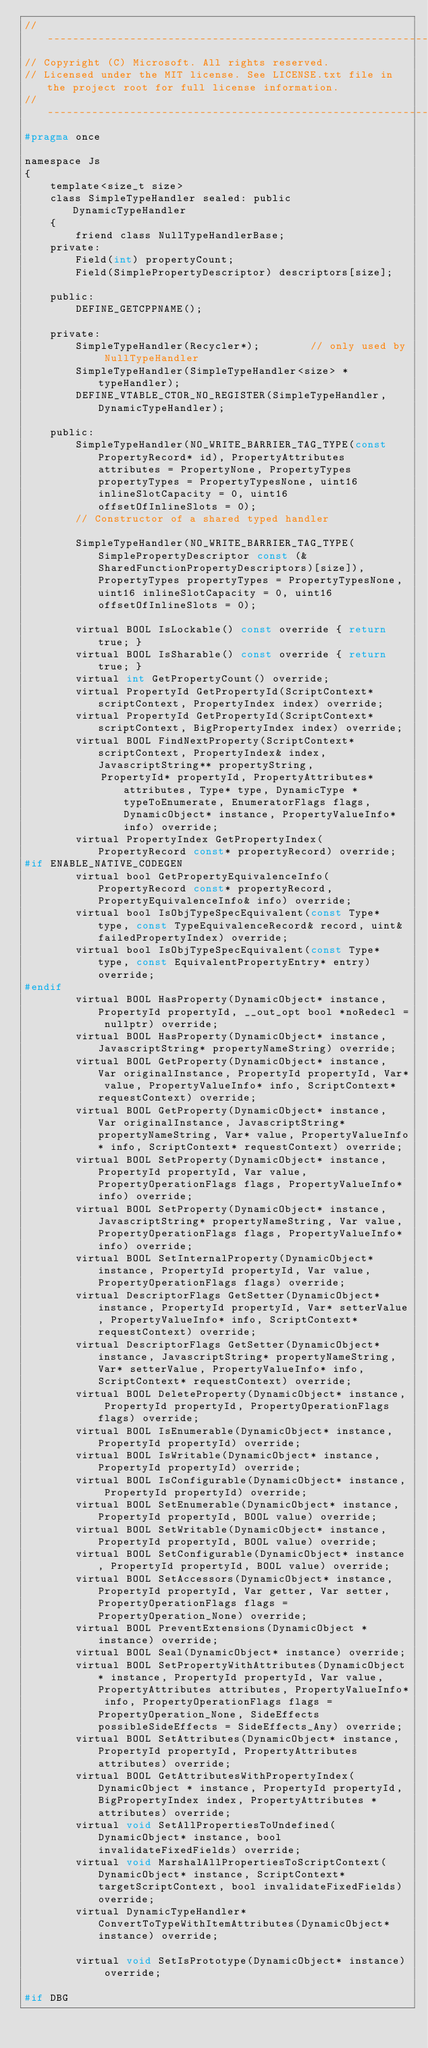Convert code to text. <code><loc_0><loc_0><loc_500><loc_500><_C_>//-------------------------------------------------------------------------------------------------------
// Copyright (C) Microsoft. All rights reserved.
// Licensed under the MIT license. See LICENSE.txt file in the project root for full license information.
//-------------------------------------------------------------------------------------------------------
#pragma once

namespace Js
{
    template<size_t size>
    class SimpleTypeHandler sealed: public DynamicTypeHandler
    {
        friend class NullTypeHandlerBase;
    private:
        Field(int) propertyCount;
        Field(SimplePropertyDescriptor) descriptors[size];

    public:
        DEFINE_GETCPPNAME();

    private:
        SimpleTypeHandler(Recycler*);        // only used by NullTypeHandler
        SimpleTypeHandler(SimpleTypeHandler<size> * typeHandler);
        DEFINE_VTABLE_CTOR_NO_REGISTER(SimpleTypeHandler, DynamicTypeHandler);

    public:
        SimpleTypeHandler(NO_WRITE_BARRIER_TAG_TYPE(const PropertyRecord* id), PropertyAttributes attributes = PropertyNone, PropertyTypes propertyTypes = PropertyTypesNone, uint16 inlineSlotCapacity = 0, uint16 offsetOfInlineSlots = 0);
        // Constructor of a shared typed handler

        SimpleTypeHandler(NO_WRITE_BARRIER_TAG_TYPE(SimplePropertyDescriptor const (&SharedFunctionPropertyDescriptors)[size]), PropertyTypes propertyTypes = PropertyTypesNone, uint16 inlineSlotCapacity = 0, uint16 offsetOfInlineSlots = 0);

        virtual BOOL IsLockable() const override { return true; }
        virtual BOOL IsSharable() const override { return true; }
        virtual int GetPropertyCount() override;
        virtual PropertyId GetPropertyId(ScriptContext* scriptContext, PropertyIndex index) override;
        virtual PropertyId GetPropertyId(ScriptContext* scriptContext, BigPropertyIndex index) override;
        virtual BOOL FindNextProperty(ScriptContext* scriptContext, PropertyIndex& index, JavascriptString** propertyString,
            PropertyId* propertyId, PropertyAttributes* attributes, Type* type, DynamicType *typeToEnumerate, EnumeratorFlags flags, DynamicObject* instance, PropertyValueInfo* info) override;
        virtual PropertyIndex GetPropertyIndex(PropertyRecord const* propertyRecord) override;
#if ENABLE_NATIVE_CODEGEN
        virtual bool GetPropertyEquivalenceInfo(PropertyRecord const* propertyRecord, PropertyEquivalenceInfo& info) override;
        virtual bool IsObjTypeSpecEquivalent(const Type* type, const TypeEquivalenceRecord& record, uint& failedPropertyIndex) override;
        virtual bool IsObjTypeSpecEquivalent(const Type* type, const EquivalentPropertyEntry* entry) override;
#endif
        virtual BOOL HasProperty(DynamicObject* instance, PropertyId propertyId, __out_opt bool *noRedecl = nullptr) override;
        virtual BOOL HasProperty(DynamicObject* instance, JavascriptString* propertyNameString) override;
        virtual BOOL GetProperty(DynamicObject* instance, Var originalInstance, PropertyId propertyId, Var* value, PropertyValueInfo* info, ScriptContext* requestContext) override;
        virtual BOOL GetProperty(DynamicObject* instance, Var originalInstance, JavascriptString* propertyNameString, Var* value, PropertyValueInfo* info, ScriptContext* requestContext) override;
        virtual BOOL SetProperty(DynamicObject* instance, PropertyId propertyId, Var value, PropertyOperationFlags flags, PropertyValueInfo* info) override;
        virtual BOOL SetProperty(DynamicObject* instance, JavascriptString* propertyNameString, Var value, PropertyOperationFlags flags, PropertyValueInfo* info) override;
        virtual BOOL SetInternalProperty(DynamicObject* instance, PropertyId propertyId, Var value, PropertyOperationFlags flags) override;
        virtual DescriptorFlags GetSetter(DynamicObject* instance, PropertyId propertyId, Var* setterValue, PropertyValueInfo* info, ScriptContext* requestContext) override;
        virtual DescriptorFlags GetSetter(DynamicObject* instance, JavascriptString* propertyNameString, Var* setterValue, PropertyValueInfo* info, ScriptContext* requestContext) override;
        virtual BOOL DeleteProperty(DynamicObject* instance, PropertyId propertyId, PropertyOperationFlags flags) override;
        virtual BOOL IsEnumerable(DynamicObject* instance, PropertyId propertyId) override;
        virtual BOOL IsWritable(DynamicObject* instance, PropertyId propertyId) override;
        virtual BOOL IsConfigurable(DynamicObject* instance, PropertyId propertyId) override;
        virtual BOOL SetEnumerable(DynamicObject* instance, PropertyId propertyId, BOOL value) override;
        virtual BOOL SetWritable(DynamicObject* instance, PropertyId propertyId, BOOL value) override;
        virtual BOOL SetConfigurable(DynamicObject* instance, PropertyId propertyId, BOOL value) override;
        virtual BOOL SetAccessors(DynamicObject* instance, PropertyId propertyId, Var getter, Var setter, PropertyOperationFlags flags = PropertyOperation_None) override;
        virtual BOOL PreventExtensions(DynamicObject *instance) override;
        virtual BOOL Seal(DynamicObject* instance) override;
        virtual BOOL SetPropertyWithAttributes(DynamicObject* instance, PropertyId propertyId, Var value, PropertyAttributes attributes, PropertyValueInfo* info, PropertyOperationFlags flags = PropertyOperation_None, SideEffects possibleSideEffects = SideEffects_Any) override;
        virtual BOOL SetAttributes(DynamicObject* instance, PropertyId propertyId, PropertyAttributes attributes) override;
        virtual BOOL GetAttributesWithPropertyIndex(DynamicObject * instance, PropertyId propertyId, BigPropertyIndex index, PropertyAttributes * attributes) override;
        virtual void SetAllPropertiesToUndefined(DynamicObject* instance, bool invalidateFixedFields) override;
        virtual void MarshalAllPropertiesToScriptContext(DynamicObject* instance, ScriptContext* targetScriptContext, bool invalidateFixedFields) override;
        virtual DynamicTypeHandler* ConvertToTypeWithItemAttributes(DynamicObject* instance) override;

        virtual void SetIsPrototype(DynamicObject* instance) override;

#if DBG</code> 